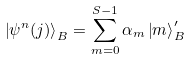Convert formula to latex. <formula><loc_0><loc_0><loc_500><loc_500>\left | \psi ^ { n } ( j ) \right \rangle _ { B } = \sum _ { m = 0 } ^ { S - 1 } \alpha _ { m } \left | m \right \rangle _ { B } ^ { \prime }</formula> 